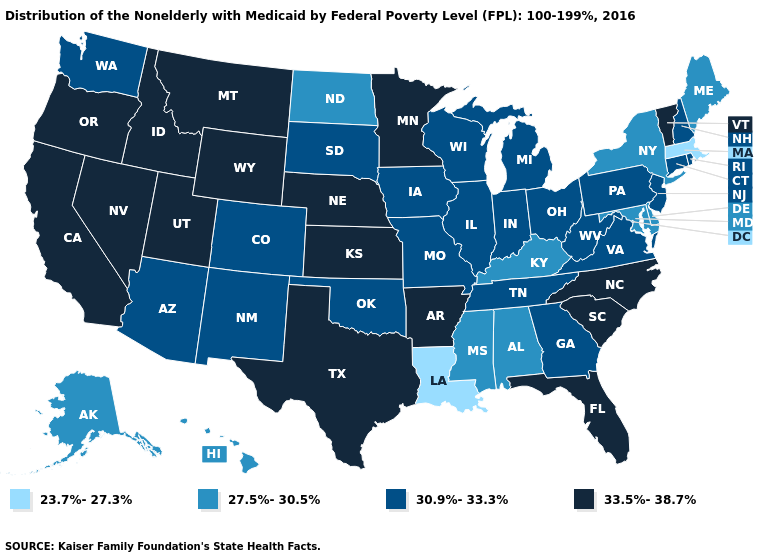Name the states that have a value in the range 33.5%-38.7%?
Quick response, please. Arkansas, California, Florida, Idaho, Kansas, Minnesota, Montana, Nebraska, Nevada, North Carolina, Oregon, South Carolina, Texas, Utah, Vermont, Wyoming. Name the states that have a value in the range 30.9%-33.3%?
Concise answer only. Arizona, Colorado, Connecticut, Georgia, Illinois, Indiana, Iowa, Michigan, Missouri, New Hampshire, New Jersey, New Mexico, Ohio, Oklahoma, Pennsylvania, Rhode Island, South Dakota, Tennessee, Virginia, Washington, West Virginia, Wisconsin. What is the value of Connecticut?
Be succinct. 30.9%-33.3%. Does the first symbol in the legend represent the smallest category?
Answer briefly. Yes. Which states have the lowest value in the West?
Short answer required. Alaska, Hawaii. What is the value of Michigan?
Write a very short answer. 30.9%-33.3%. Which states have the lowest value in the Northeast?
Keep it brief. Massachusetts. What is the highest value in states that border West Virginia?
Give a very brief answer. 30.9%-33.3%. Does Louisiana have the lowest value in the South?
Keep it brief. Yes. What is the value of Georgia?
Write a very short answer. 30.9%-33.3%. What is the value of Rhode Island?
Quick response, please. 30.9%-33.3%. What is the lowest value in the MidWest?
Short answer required. 27.5%-30.5%. Does the map have missing data?
Write a very short answer. No. Name the states that have a value in the range 33.5%-38.7%?
Write a very short answer. Arkansas, California, Florida, Idaho, Kansas, Minnesota, Montana, Nebraska, Nevada, North Carolina, Oregon, South Carolina, Texas, Utah, Vermont, Wyoming. Among the states that border Georgia , does Alabama have the lowest value?
Answer briefly. Yes. 